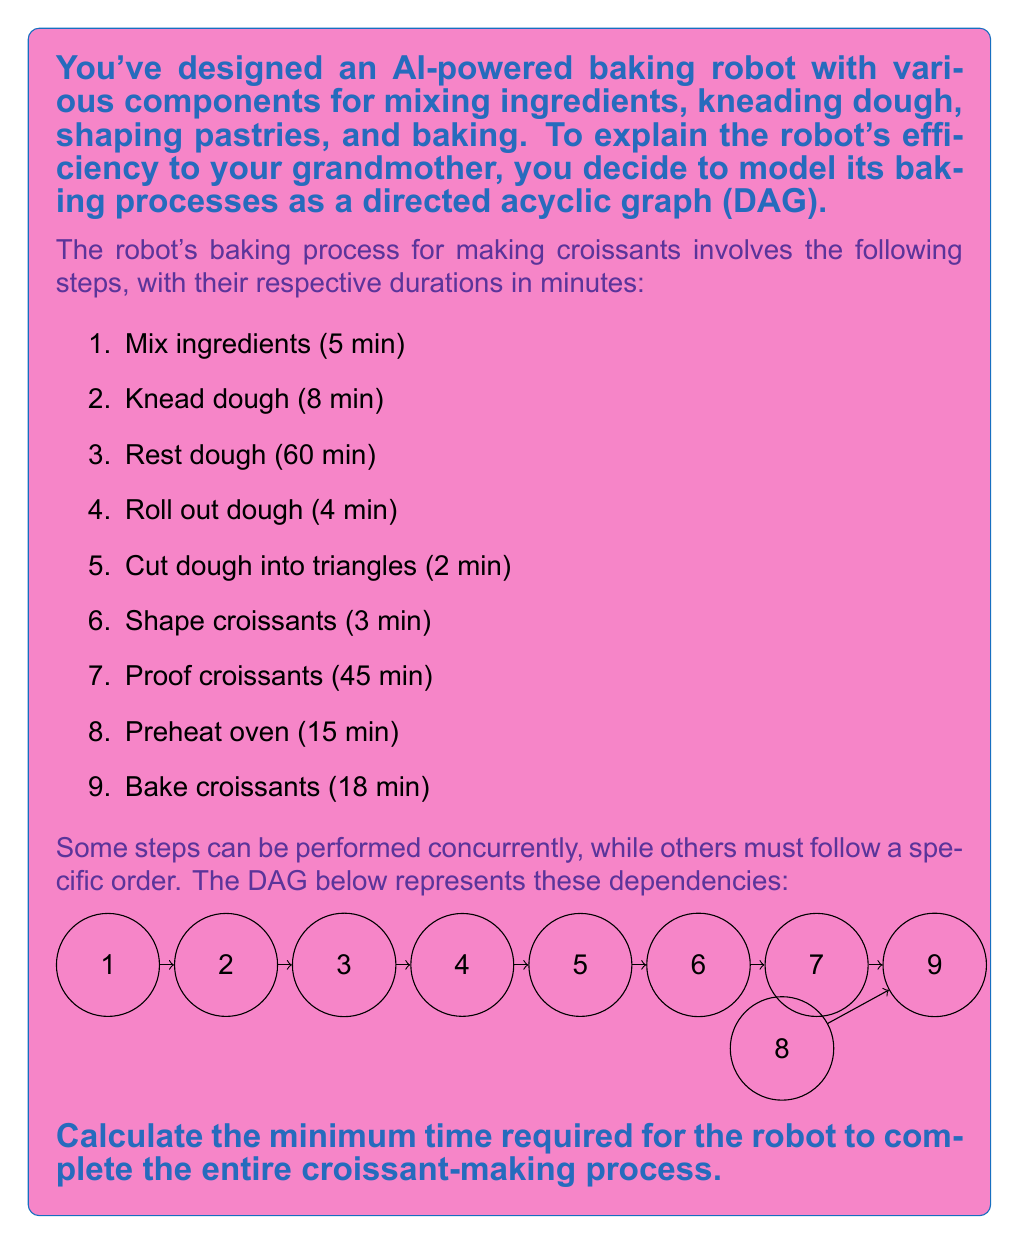Help me with this question. To solve this problem, we need to find the critical path in the directed acyclic graph (DAG) that represents the baking process. The critical path is the longest path through the network of tasks, which determines the minimum time required to complete the entire process.

Let's analyze the graph step by step:

1. Identify the paths:
   Path 1: 1 -> 2 -> 3 -> 4 -> 5 -> 6 -> 7 -> 9
   Path 2: 8 -> 9

2. Calculate the duration of each path:
   Path 1: 5 + 8 + 60 + 4 + 2 + 3 + 45 + 18 = 145 minutes
   Path 2: 15 + 18 = 33 minutes

3. Determine the critical path:
   The critical path is the longer of the two paths, which is Path 1 with 145 minutes.

4. Check for concurrent operations:
   Step 8 (Preheat oven) can be performed concurrently with steps 1-7. Since its duration (15 minutes) is shorter than the total duration of steps 1-7 (127 minutes), it doesn't add to the total time.

Therefore, the minimum time required for the robot to complete the entire croissant-making process is determined by the critical path, which is 145 minutes.

This approach demonstrates the efficiency of the AI-powered baking robot by showing how it optimizes the process by performing concurrent tasks when possible.
Answer: 145 minutes 